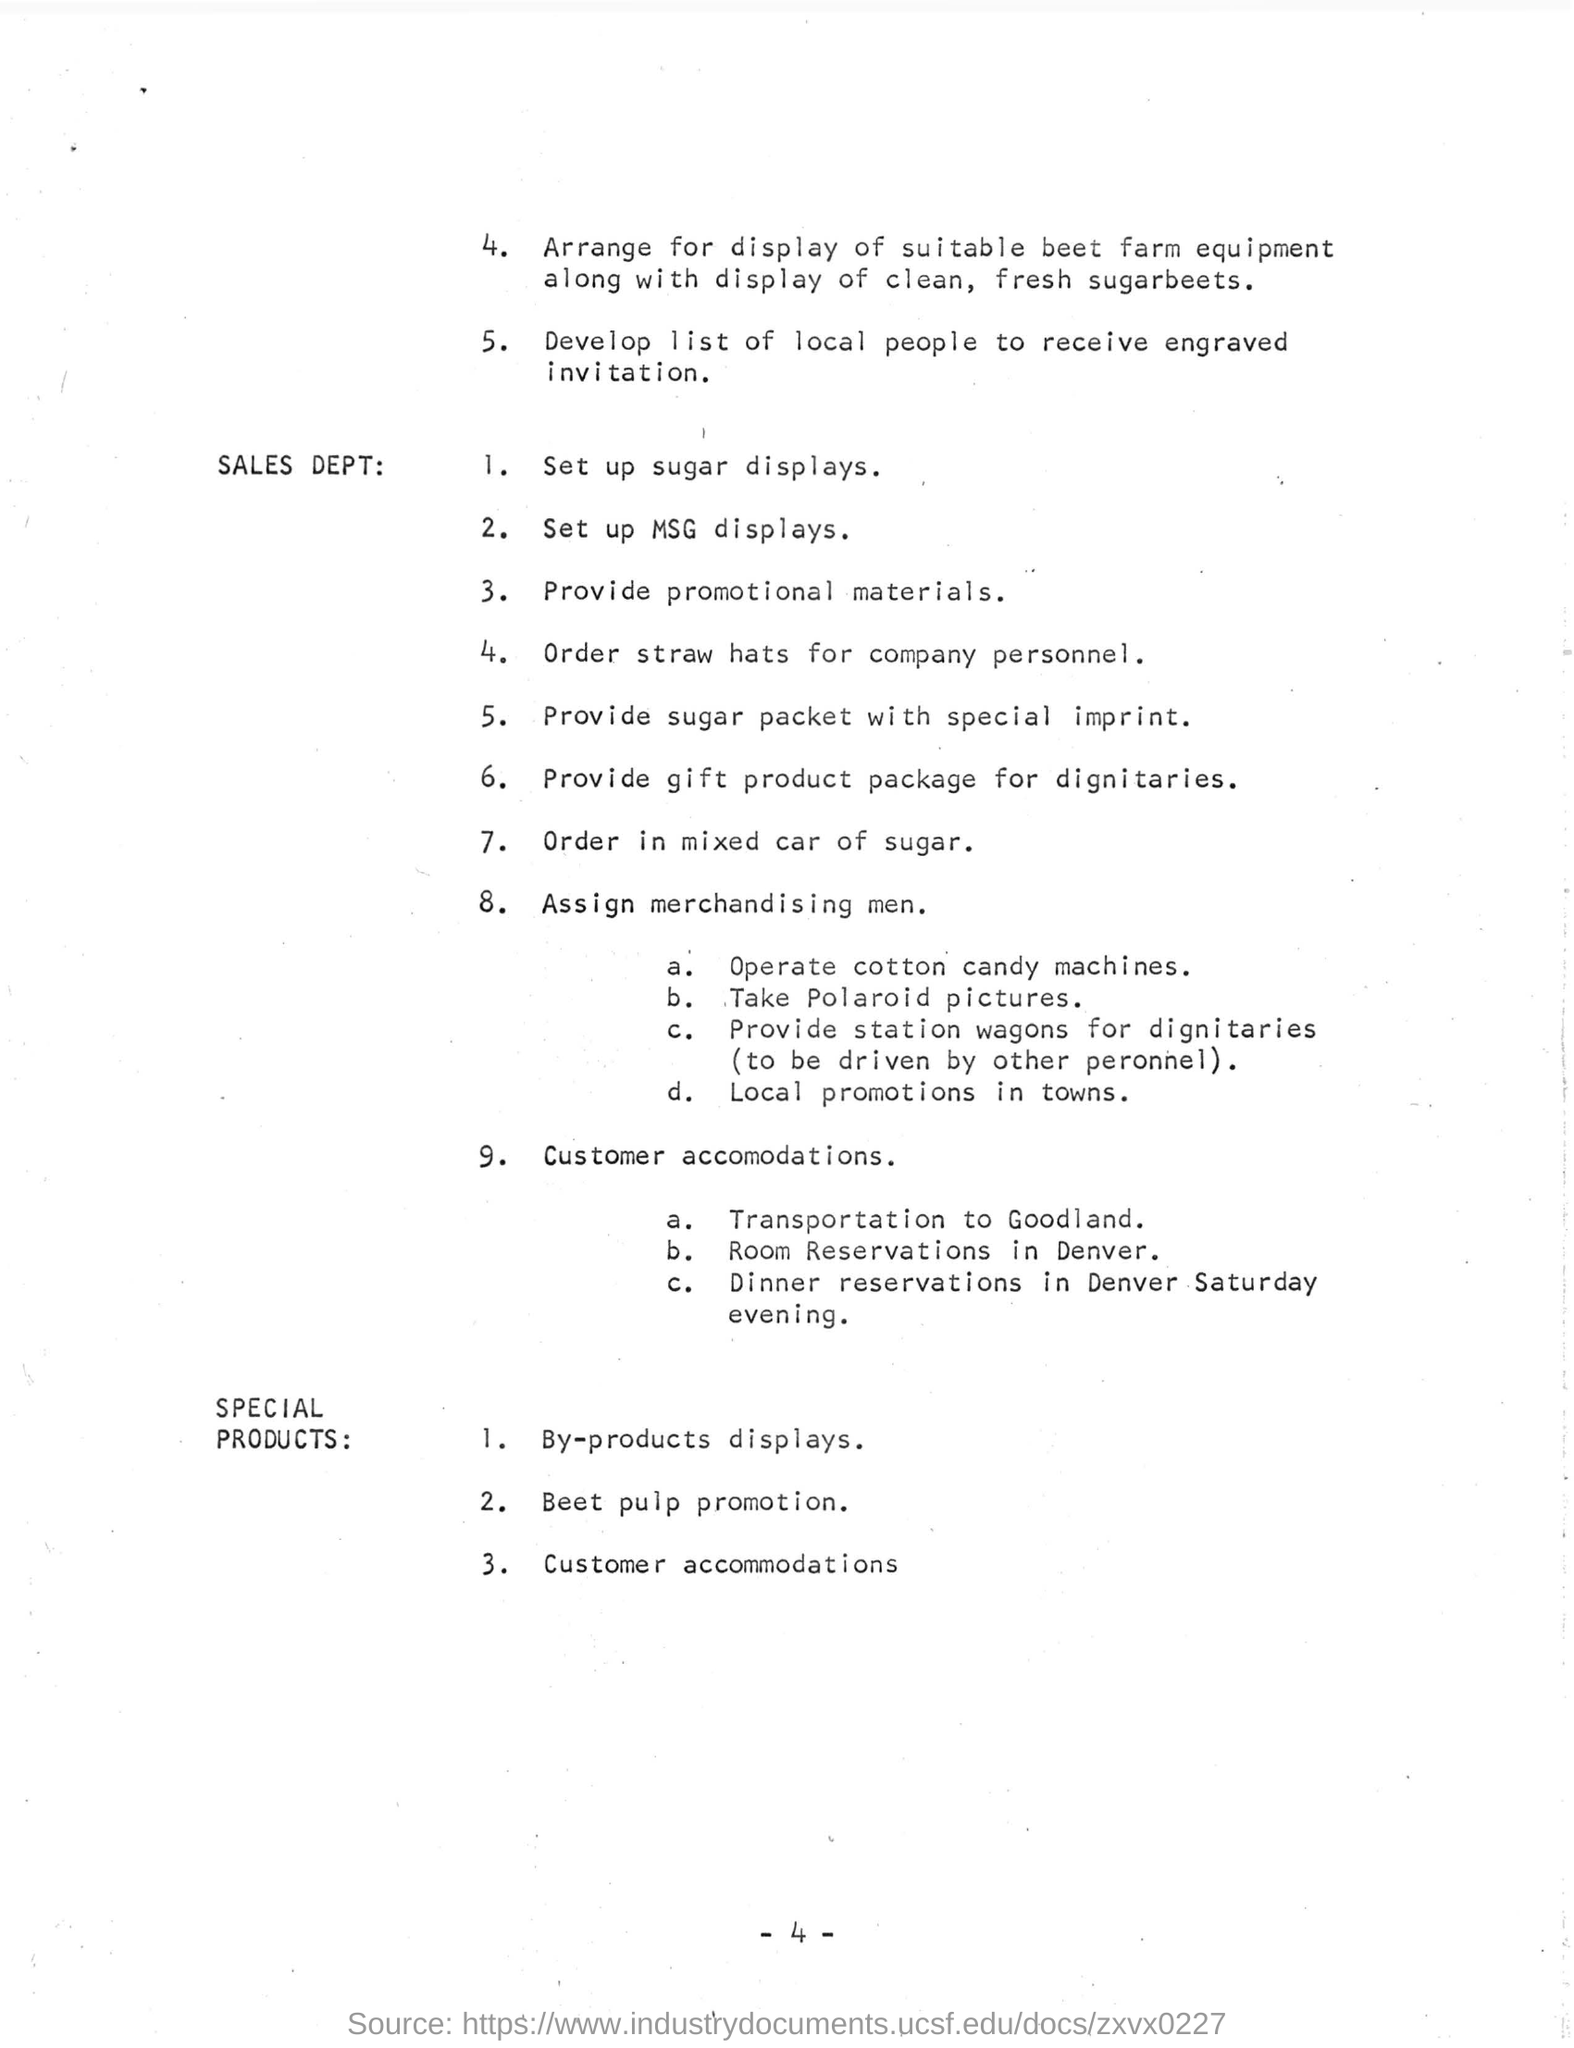What type of hats should be ordered for company personnel?
Provide a succinct answer. Straw. Who should be provided with gift product packages?
Offer a very short reply. DIGNITARIES. Where is Room Reservation for customers provided?
Make the answer very short. DENVER. 